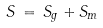Convert formula to latex. <formula><loc_0><loc_0><loc_500><loc_500>S \, = \, S _ { g } + S _ { m }</formula> 